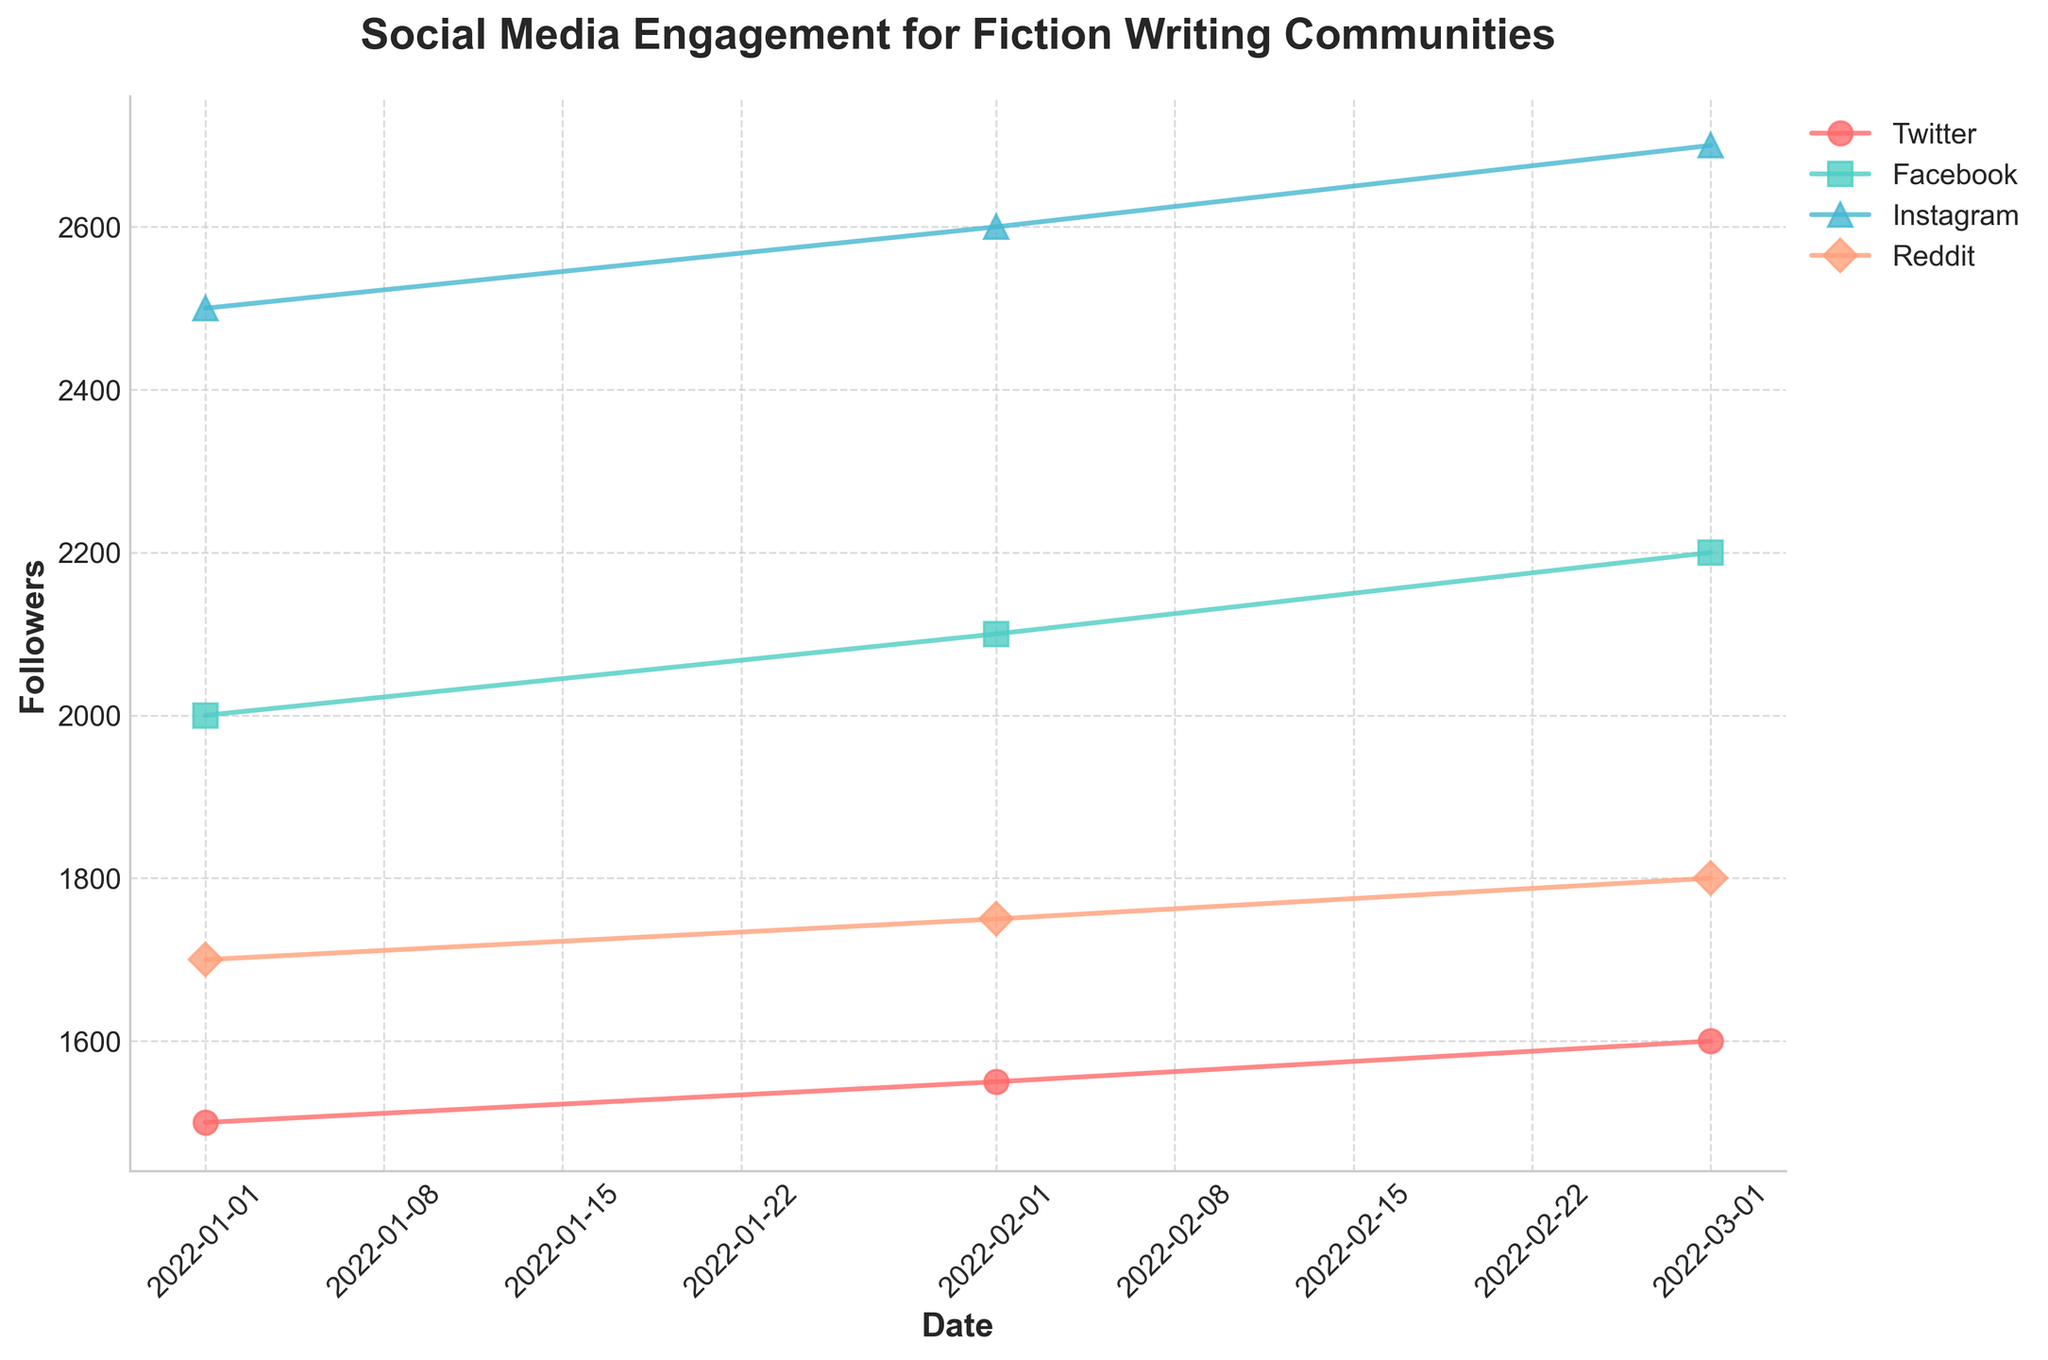What is the title of the figure? The title is displayed at the top of the figure.
Answer: Social Media Engagement for Fiction Writing Communities Which platform had the highest number of followers in March 2022? Find the data point for each platform in March 2022 and identify the highest value.
Answer: Instagram How did the number of followers on Facebook change from January to March 2022? Compare the number of followers on Facebook in January and March 2022 and calculate the difference.
Answer: Increased by 200 Which platform showed the smallest growth in followers from January to March 2022? Compute the difference in followers from January to March 2022 for each platform and find the smallest value.
Answer: Reddit How many platforms are represented in the figure? Count the unique platforms displayed in the label of the figure.
Answer: Four Which month showed the highest number of Instagram followers and what was the value? Observe the Instagram followers plot and identify the month with the highest value.
Answer: March 2022, 2700 By how much did the total number of followers increase across all platforms from January to February 2022? Sum the increase in followers for each platform between January and February 2022.
Answer: 200 Which platform had the steepest increase in followers over the three months? Compare the slopes of each platform's follower increase and identify the steepest one.
Answer: Facebook How many unique data points are plotted for each platform? Count the number of data points shown for each platform in the figure.
Answer: Three per platform What is the average number of followers on Twitter over the given time period? Add the number of followers on Twitter for each month and divide by the number of months. (1500 + 1550 + 1600) / 3
Answer: 1550 